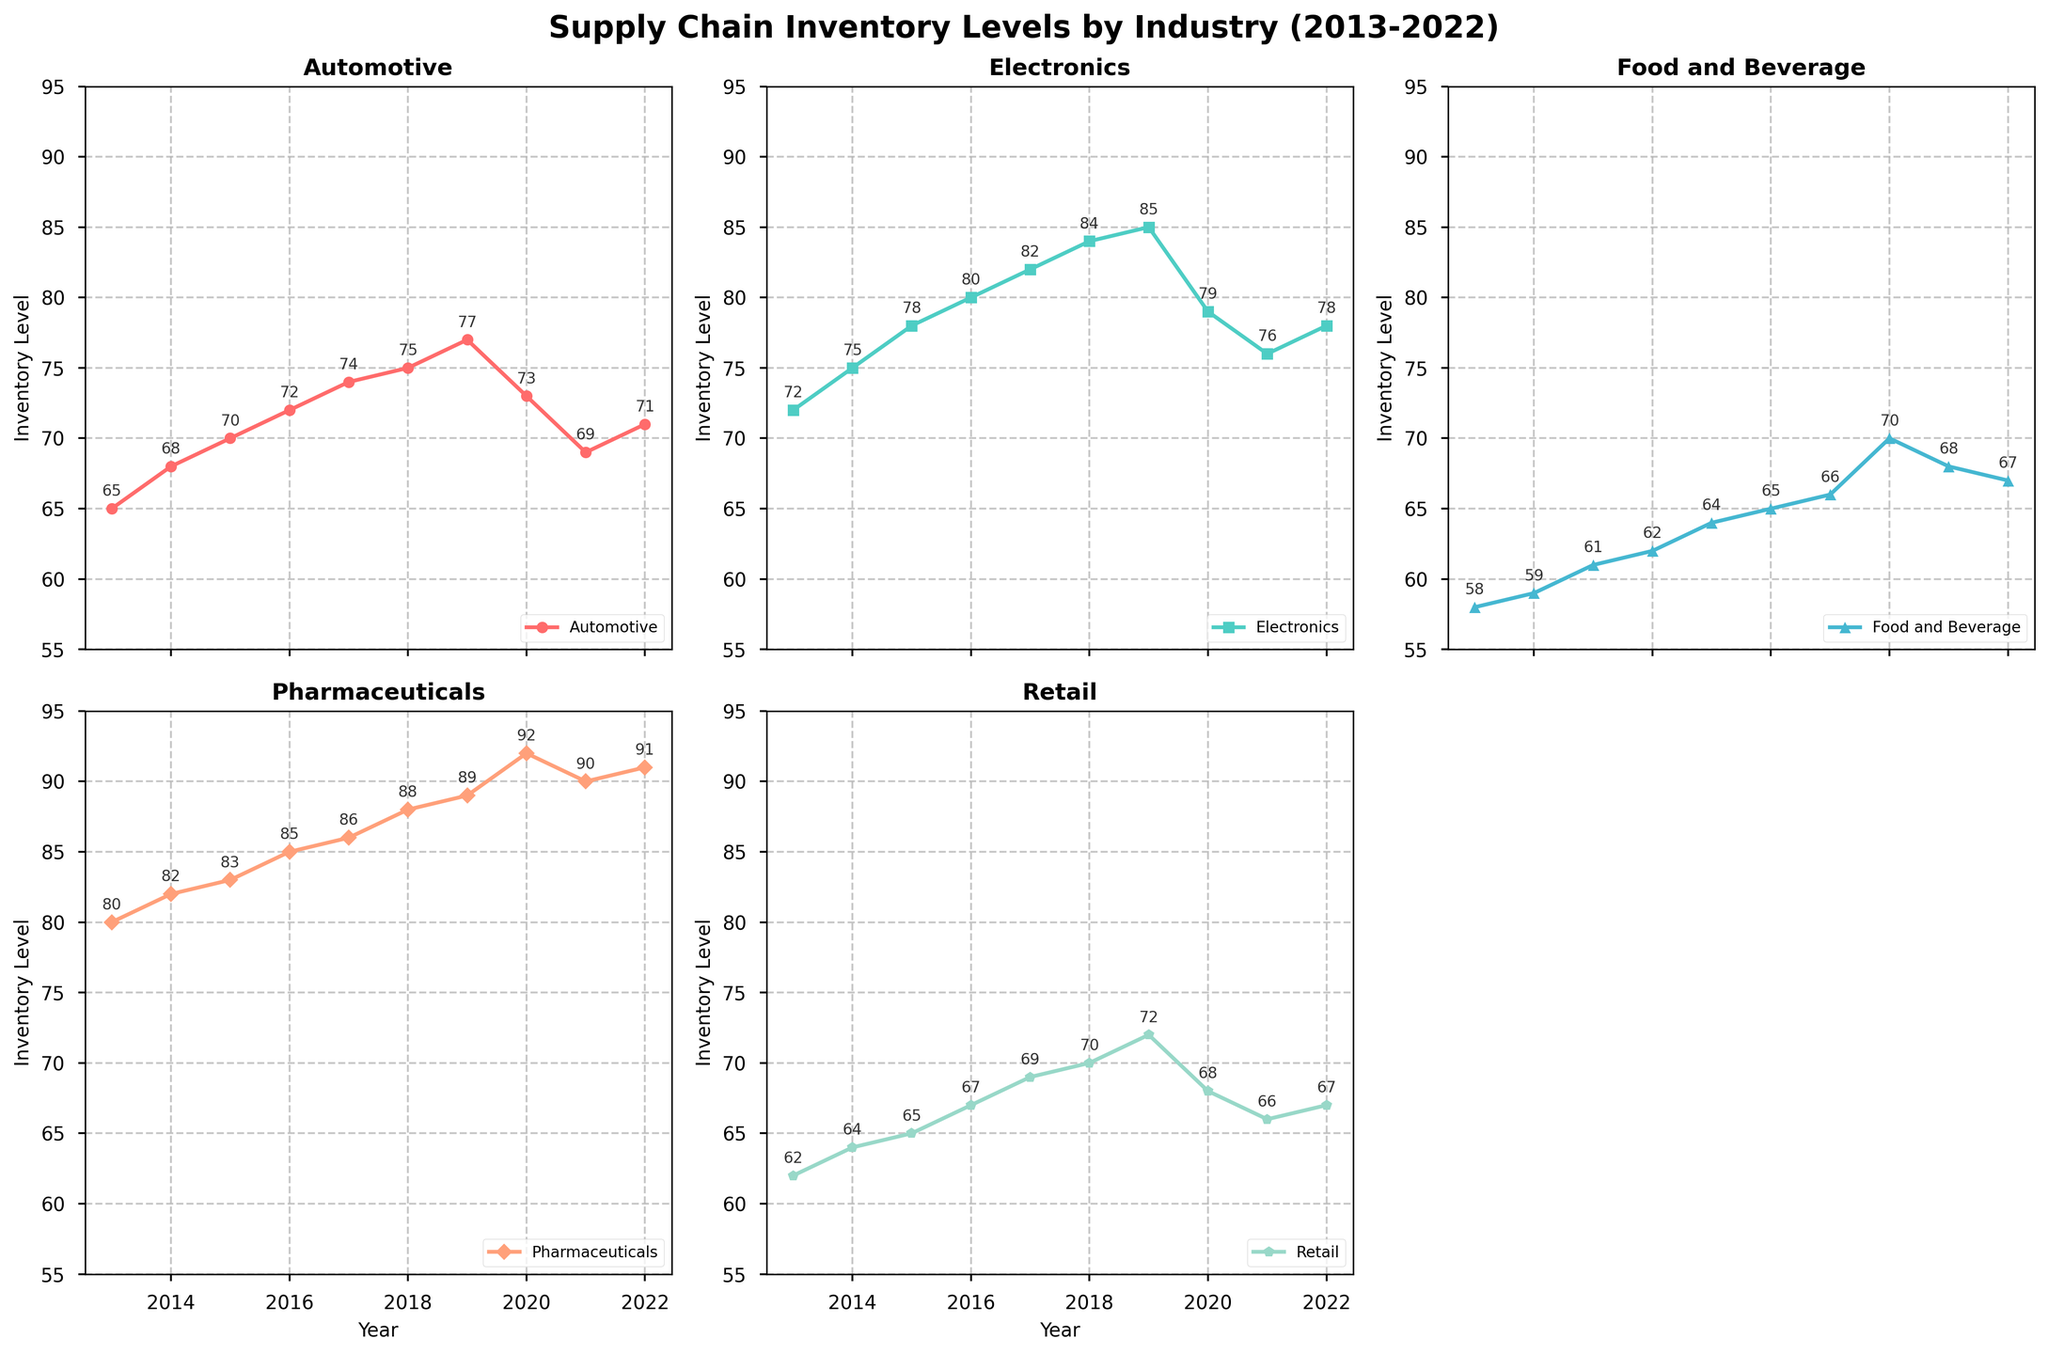What is the average inventory level of the Electronics industry from 2013 to 2022? To find the average, sum up the inventory levels for Electronics over all years (72 + 75 + 78 + 80 + 82 + 84 + 85 + 79 + 76 + 78 = 789) and divide by the number of years (10). So, the average is 789 / 10 = 78.9.
Answer: 78.9 Which industry had the highest inventory level in 2020? Check the data points for 2020 across all subplots. The inventory level in the Pharmaceuticals subplot shows the highest value at 92.
Answer: Pharmaceuticals In which year did the Retail industry have the lowest inventory level? By examining the Retail subplot, we see that the lowest inventory level for Retail occurred in 2021 with a value of 66.
Answer: 2021 What is the difference between the inventory levels of the Automotive and Pharmaceuticals industries in 2018? From the subplots, the inventory levels in 2018 are 75 for Automotive and 88 for Pharmaceuticals. The difference is 88 - 75 = 13.
Answer: 13 Is there any industry that shows a consistent increase in inventory levels from 2013 to 2019? Looking through each subplot, we see that the Pharmaceuticals industry's inventory levels consistently increased from 2013 through 2019 (80, 82, 83, 85, 86, 88, 89).
Answer: Yes, Pharmaceuticals Which two industries had the most volatile inventory levels over the past decade? Volatile means large fluctuations. Matching this to the trends visible, Automotive and Retail show more noticeable ups and downs as compared to others, particularly in 2019-2022.
Answer: Automotive and Retail By how much did the inventory level of the Food and Beverage industry increase from 2013 to 2019? The inventory level for the Food and Beverage industry was 58 in 2013 and 66 in 2019. The increase is 66 - 58 = 8.
Answer: 8 What is the median inventory level for the Automotive industry over the past decade? Organize the inventory levels (65, 68, 70, 72, 74, 75, 77, 73, 69, 71) and find the middle value. The sorted values are (65, 68, 69, 70, 71, 72, 73, 74, 75, 77). The middle values are 71 and 72, so the median is (71 + 72)/2 = 71.5.
Answer: 71.5 